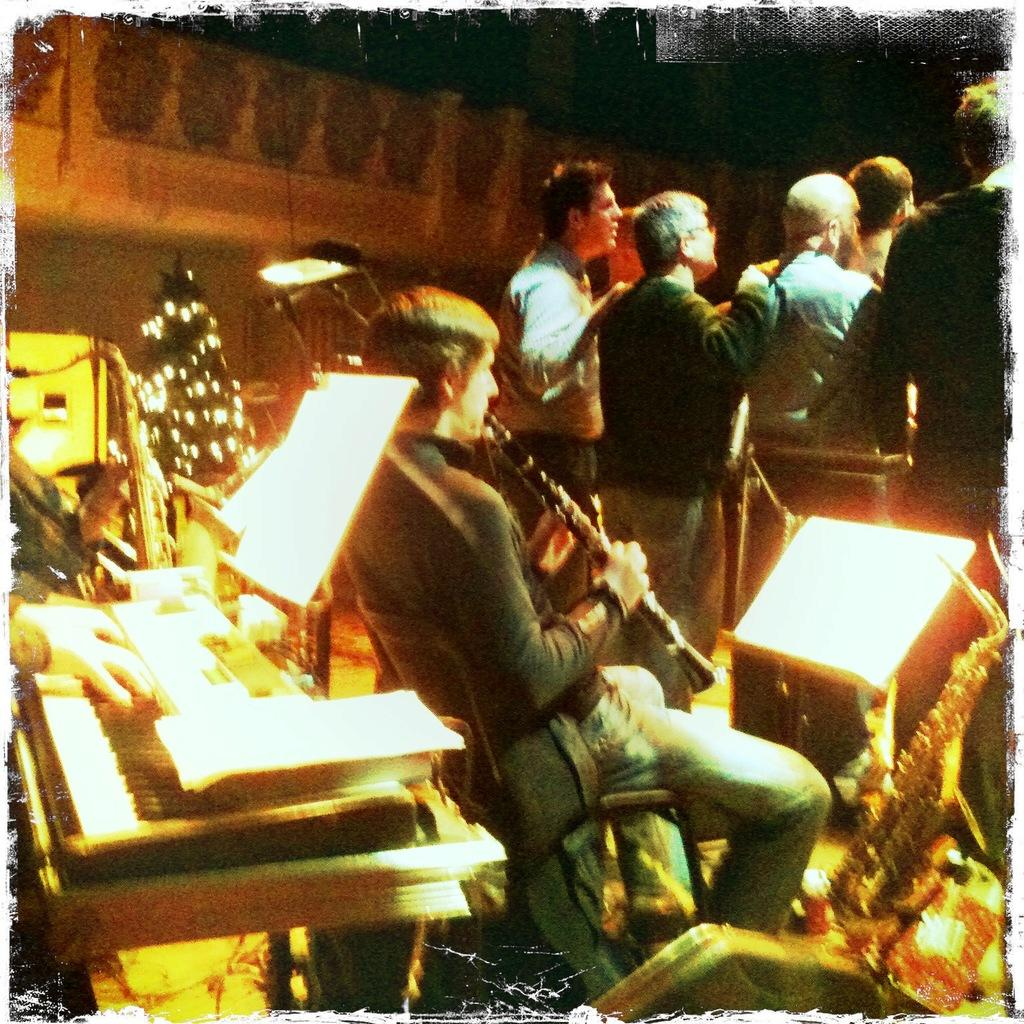How many people are in the image? There is a group of people in the image, but the exact number cannot be determined from the provided facts. What are the people in the image doing? The presence of musical instruments in the image suggests that the people might be playing music or participating in a musical activity. What can be seen in the background of the image? There is a wall in the background of the image. What type of chalk is being used by the people in the image? There is no chalk present in the image. Can you tell me how deep the water is for swimming in the image? There is no swimming or water present in the image. 